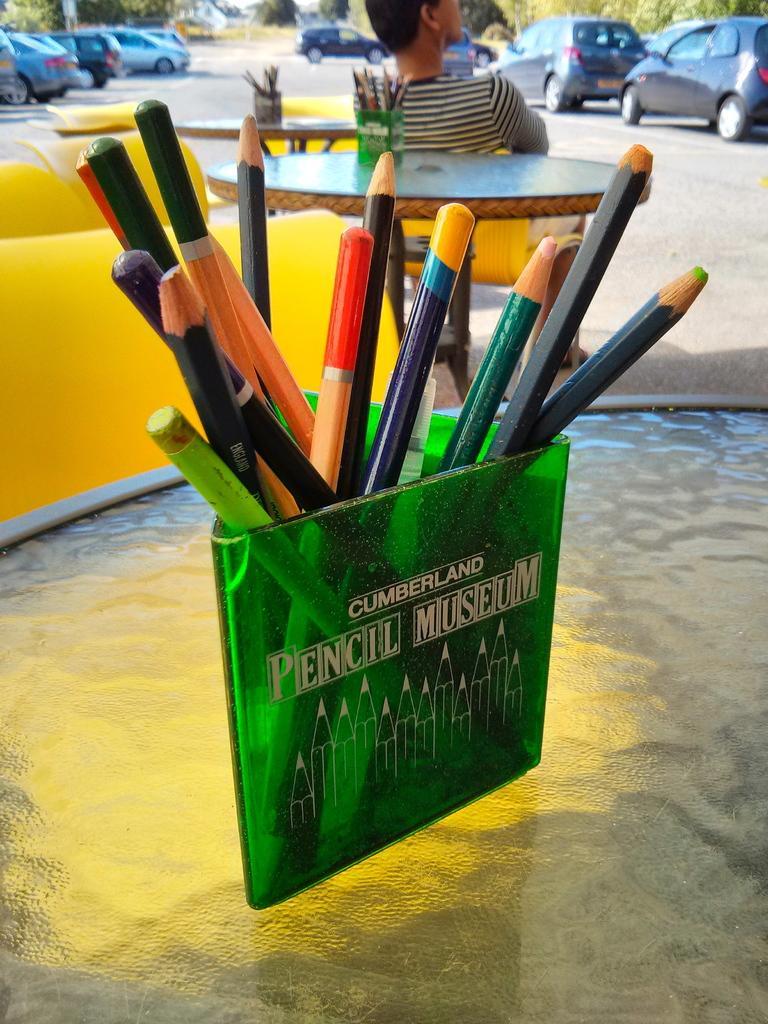Please provide a concise description of this image. In this image there are pencils in pencil stands on the tables, and there are chairs , a person sitting on a chair , there are vehicles parked on the path and there are trees. 